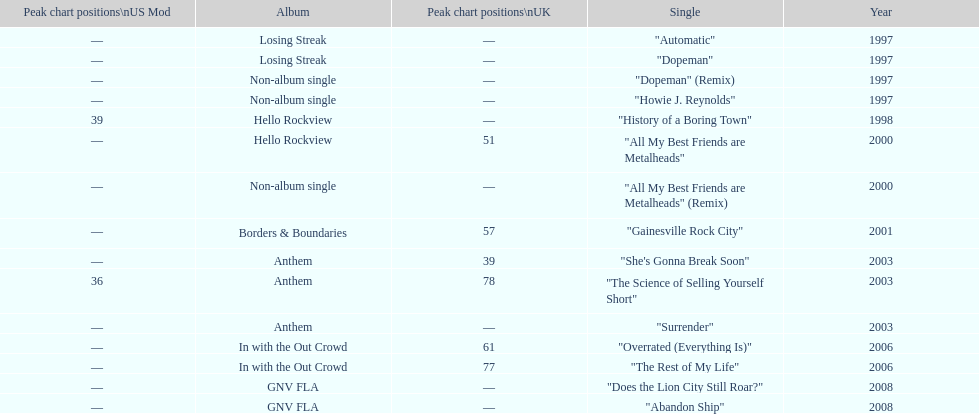Parse the table in full. {'header': ['Peak chart positions\\nUS Mod', 'Album', 'Peak chart positions\\nUK', 'Single', 'Year'], 'rows': [['—', 'Losing Streak', '—', '"Automatic"', '1997'], ['—', 'Losing Streak', '—', '"Dopeman"', '1997'], ['—', 'Non-album single', '—', '"Dopeman" (Remix)', '1997'], ['—', 'Non-album single', '—', '"Howie J. Reynolds"', '1997'], ['39', 'Hello Rockview', '—', '"History of a Boring Town"', '1998'], ['—', 'Hello Rockview', '51', '"All My Best Friends are Metalheads"', '2000'], ['—', 'Non-album single', '—', '"All My Best Friends are Metalheads" (Remix)', '2000'], ['—', 'Borders & Boundaries', '57', '"Gainesville Rock City"', '2001'], ['—', 'Anthem', '39', '"She\'s Gonna Break Soon"', '2003'], ['36', 'Anthem', '78', '"The Science of Selling Yourself Short"', '2003'], ['—', 'Anthem', '—', '"Surrender"', '2003'], ['—', 'In with the Out Crowd', '61', '"Overrated (Everything Is)"', '2006'], ['—', 'In with the Out Crowd', '77', '"The Rest of My Life"', '2006'], ['—', 'GNV FLA', '—', '"Does the Lion City Still Roar?"', '2008'], ['—', 'GNV FLA', '—', '"Abandon Ship"', '2008']]} How long was it between losing streak almbum and gnv fla in years. 11. 